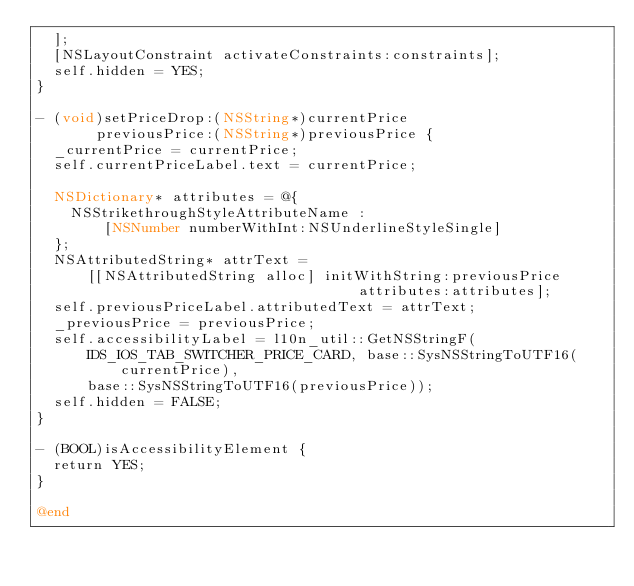Convert code to text. <code><loc_0><loc_0><loc_500><loc_500><_ObjectiveC_>  ];
  [NSLayoutConstraint activateConstraints:constraints];
  self.hidden = YES;
}

- (void)setPriceDrop:(NSString*)currentPrice
       previousPrice:(NSString*)previousPrice {
  _currentPrice = currentPrice;
  self.currentPriceLabel.text = currentPrice;

  NSDictionary* attributes = @{
    NSStrikethroughStyleAttributeName :
        [NSNumber numberWithInt:NSUnderlineStyleSingle]
  };
  NSAttributedString* attrText =
      [[NSAttributedString alloc] initWithString:previousPrice
                                      attributes:attributes];
  self.previousPriceLabel.attributedText = attrText;
  _previousPrice = previousPrice;
  self.accessibilityLabel = l10n_util::GetNSStringF(
      IDS_IOS_TAB_SWITCHER_PRICE_CARD, base::SysNSStringToUTF16(currentPrice),
      base::SysNSStringToUTF16(previousPrice));
  self.hidden = FALSE;
}

- (BOOL)isAccessibilityElement {
  return YES;
}

@end
</code> 